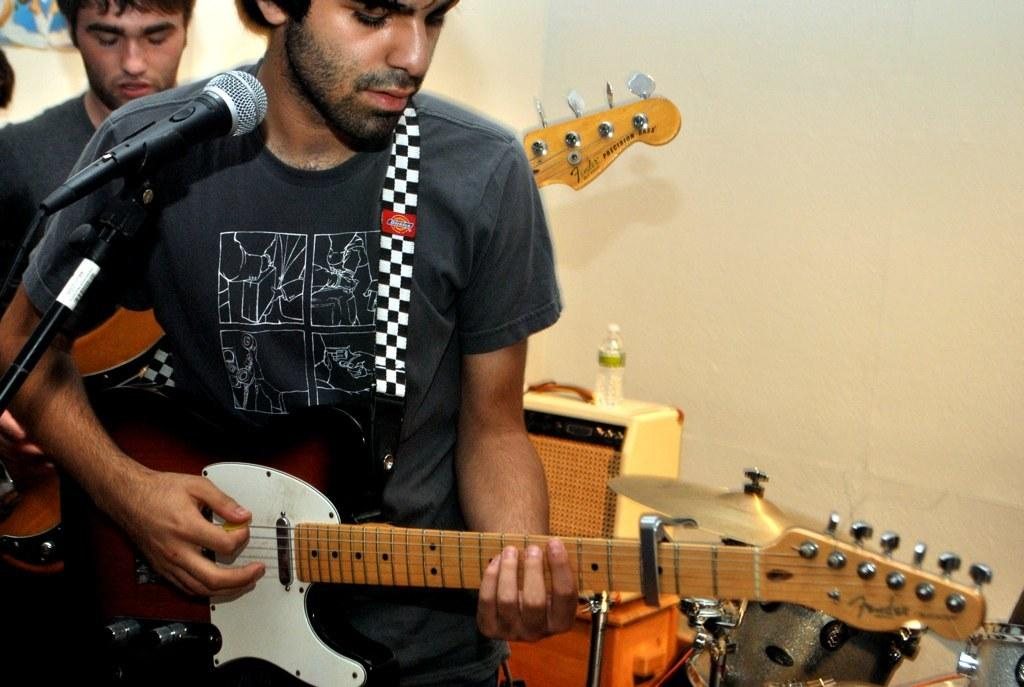How many people are in the image? There are two people in the image. What are the people doing in the image? Both people are standing and playing musical instruments. What type of lettuce can be seen in the image? There is no lettuce present in the image. What part of the glass is visible in the image? There is no glass present in the image. 